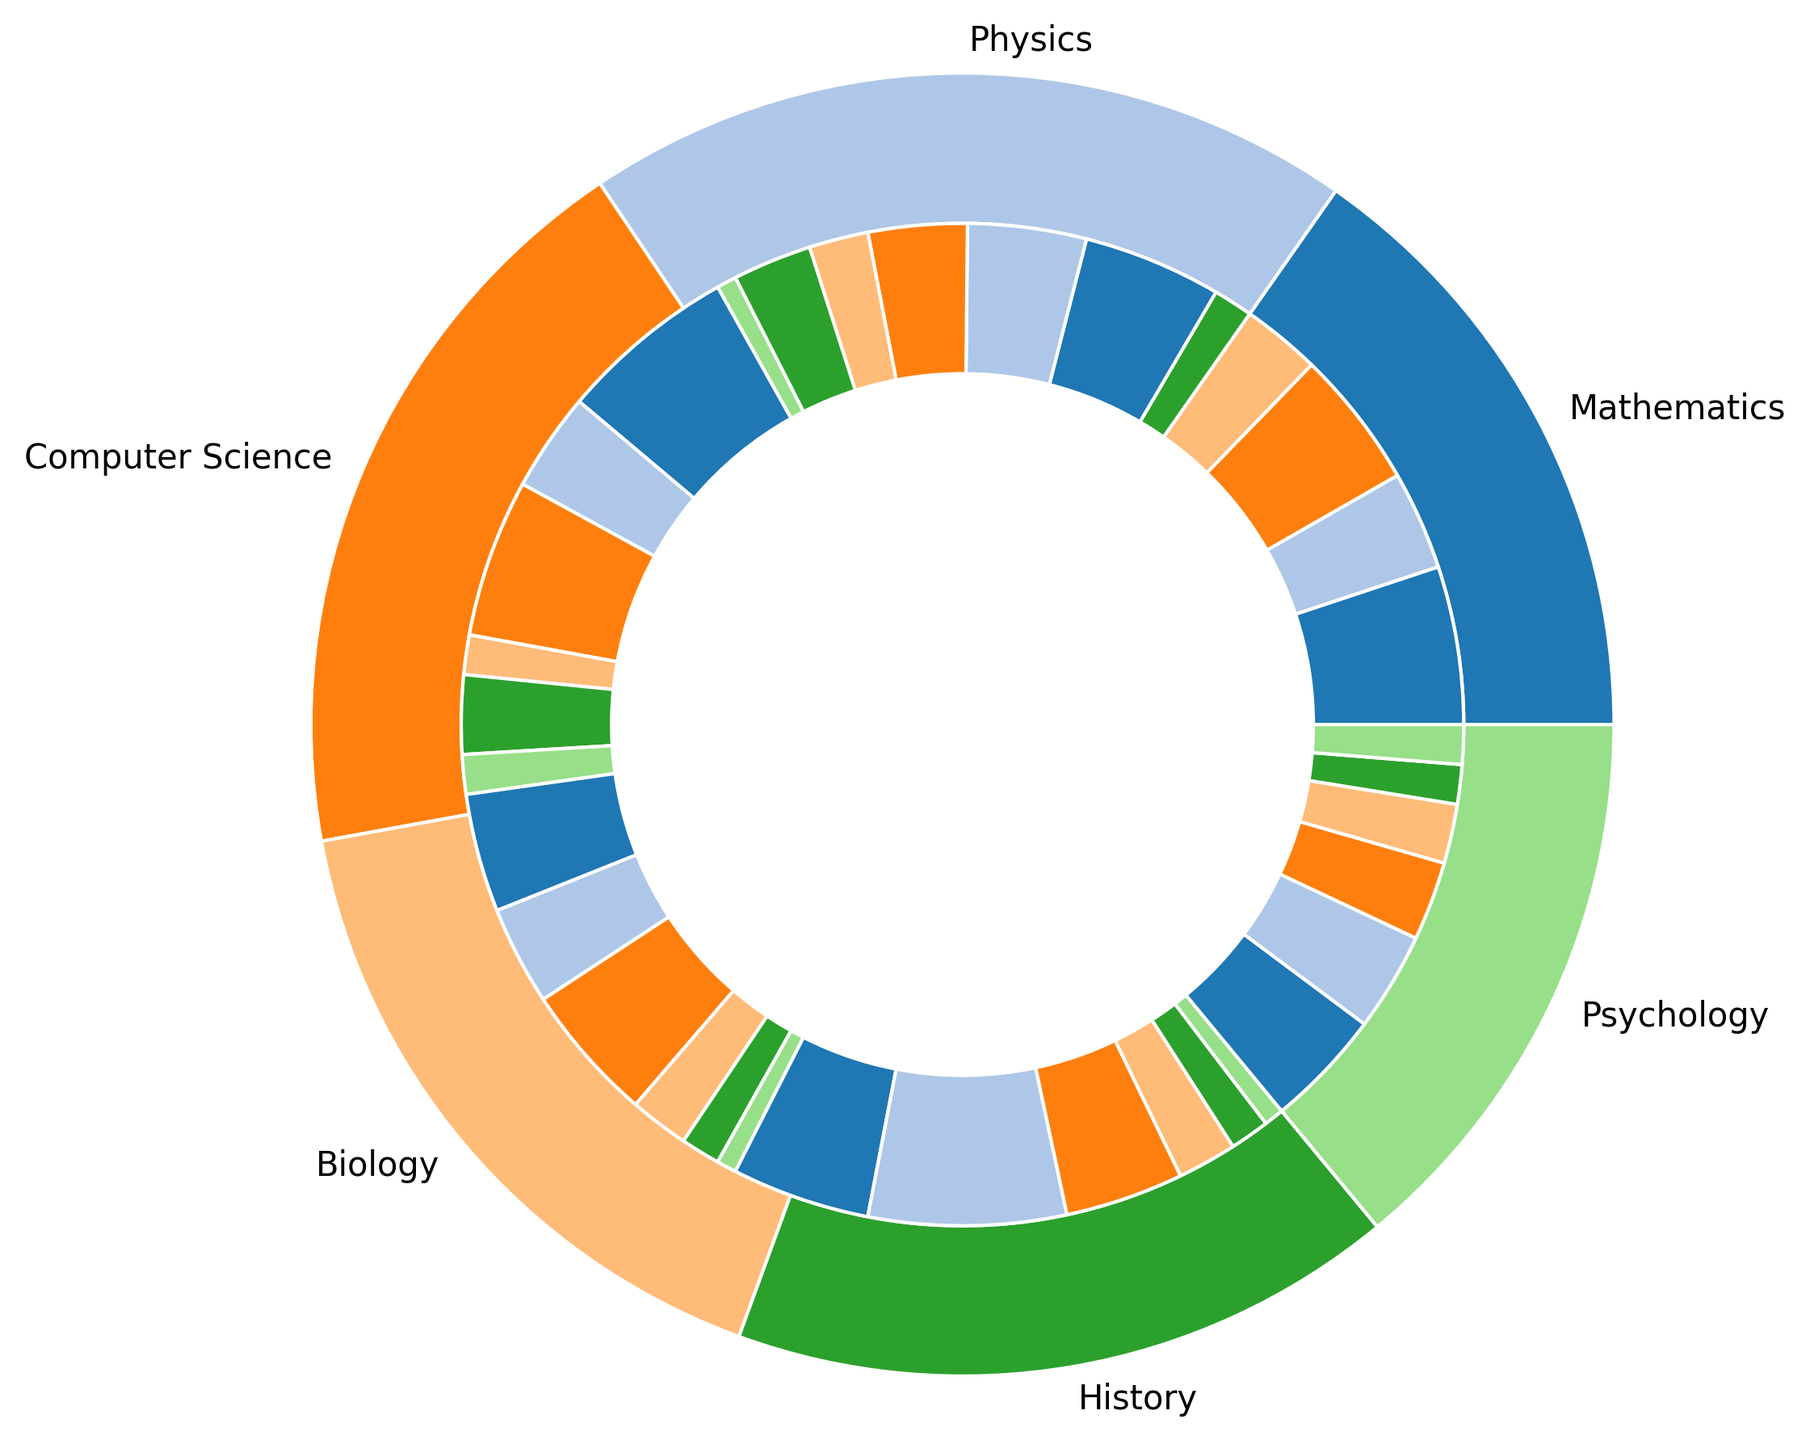What is the total weekly study time for Mathematics? Sum the study time for all the activities in Mathematics: 8 + 5 + 7 + 4 + 2 = 26 hours.
Answer: 26 hours Which subject has the longest weekly study time? Observe the outer ring of the pie chart and identify the subject with the largest segment. Based on the provided data and assuming equal segment visualization, Computer Science has the highest total: 9 + 5 + 8 + 2 + 4 + 2 = 30 hours.
Answer: Computer Science How does the weekly study time for attending lectures compare between Mathematics and Physics? Compare the segment sizes for 'Attending Lectures' for both subjects. Mathematics has 8 hours and Physics has 7 hours.
Answer: Mathematics has 1 hour more than Physics Which activity type in Biology consumes the most weekly study time? Check the inner segments of the Biology part of the chart and find the largest segment. Lab Work in Biology consumes 7 hours, which is the highest among the activities.
Answer: Lab Work What is the difference in total weekly study time between History and Psychology? Sum the study times for all activities in both subjects and then find the difference. History: 7 + 10 + 6 + 3 + 2 + 1 = 29 hours. Psychology: 6 + 5 + 4 + 3 + 2 + 2 = 22 hours. Difference: 29 - 22 = 7 hours.
Answer: 7 hours How many subjects have group study activities, and which one spends the most time on it? Identify all subjects with 'Group Study' segments and compare their values. Subjects with group study activities: Mathematics (4 hours), Physics (3 hours), Computer Science (2 hours), Biology (3 hours), History (3 hours), Psychology (3 hours). The maximum time spent is by Mathematics with 4 hours.
Answer: 6 subjects, Mathematics What is the average weekly study time for reading materials across all subjects? Sum the study times for all reading-related activities and divide by the number of such segments. Reading-related activities: Mathematics (5 hours), Physics (6 hours), Computer Science (5 hours), Biology (5 hours), History (10 hours), Psychology (5 hours). Sum = 5 + 6 + 5 + 5 + 10 + 5 = 36 hours. Number of segments = 6. Average = 36 / 6 = 6 hours.
Answer: 6 hours Which subject allocates the least time for tutoring? Identify and compare the tutoring segments across all subjects. Physics and History have the least time for tutoring with 1 hour each.
Answer: Physics and History Which subject has the most diverse types of study activities? Count the number of unique activity types for each subject. The comparison shows Computer Science and Psychology both have 6 different types of activities.
Answer: Computer Science and Psychology In which subject is the second most time-consuming activity solving problems? Check the inner segments labeled as 'Solving Problems' and compare them across subjects. Mathematics: 7 hours, Physics: 5 hours. The second highest is Physics with 5 hours.
Answer: Physics 